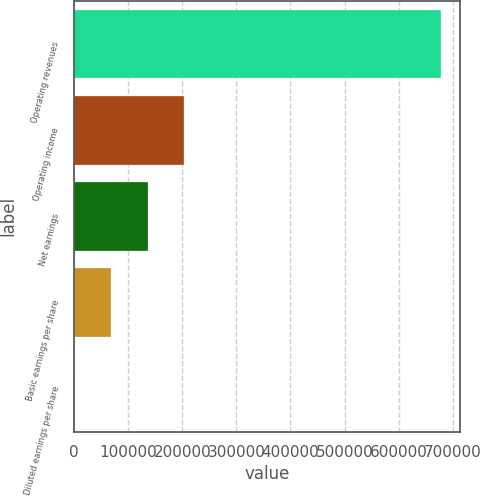<chart> <loc_0><loc_0><loc_500><loc_500><bar_chart><fcel>Operating revenues<fcel>Operating income<fcel>Net earnings<fcel>Basic earnings per share<fcel>Diluted earnings per share<nl><fcel>679037<fcel>203711<fcel>135808<fcel>67904.2<fcel>0.55<nl></chart> 